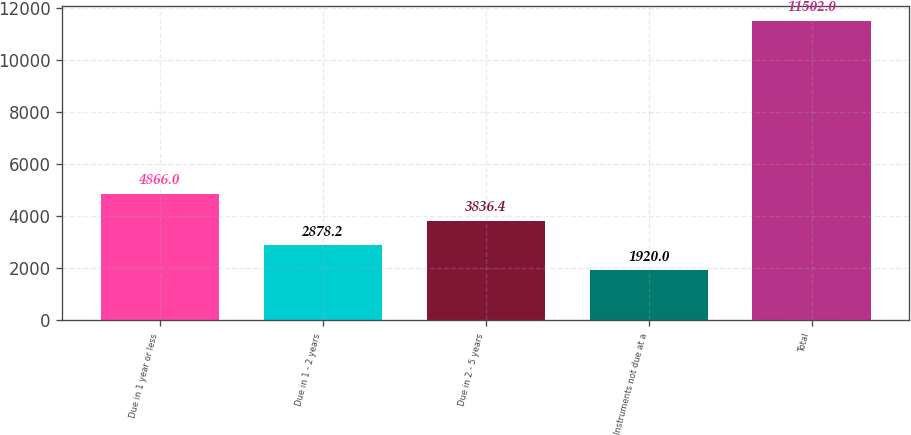Convert chart. <chart><loc_0><loc_0><loc_500><loc_500><bar_chart><fcel>Due in 1 year or less<fcel>Due in 1 - 2 years<fcel>Due in 2 - 5 years<fcel>Instruments not due at a<fcel>Total<nl><fcel>4866<fcel>2878.2<fcel>3836.4<fcel>1920<fcel>11502<nl></chart> 